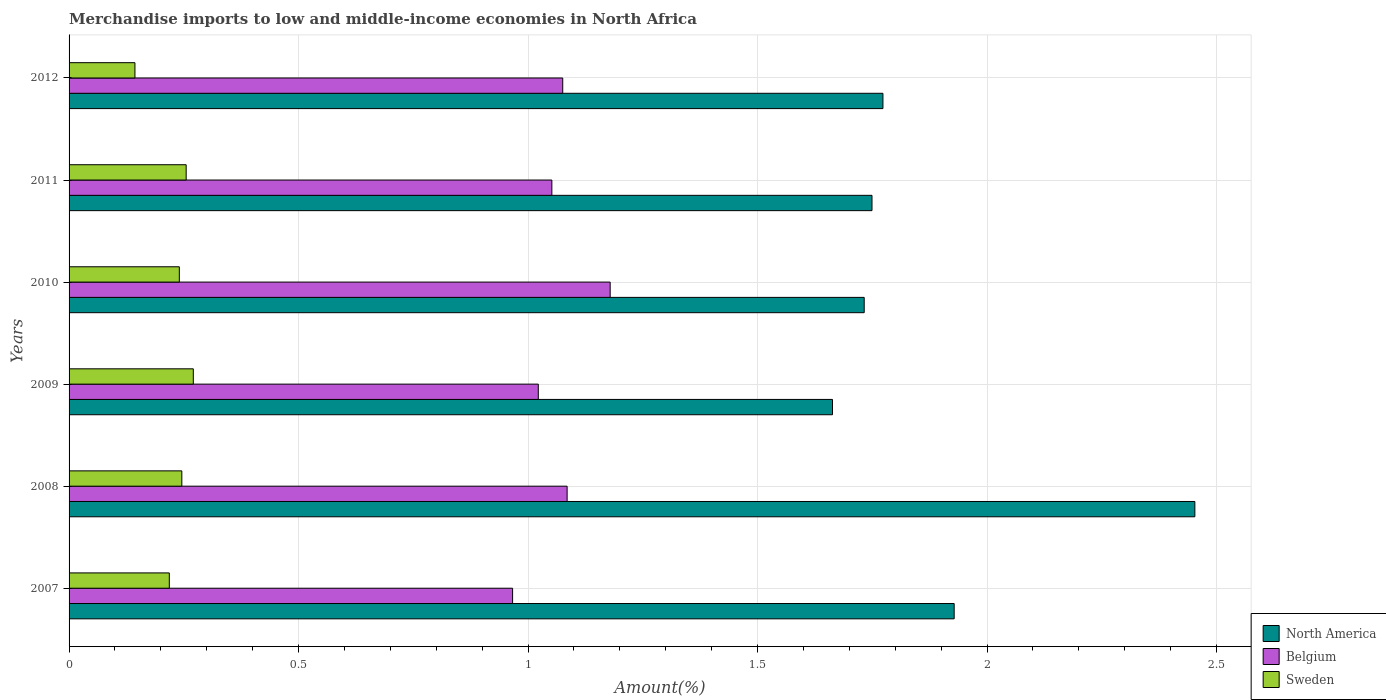How many different coloured bars are there?
Provide a short and direct response. 3. Are the number of bars per tick equal to the number of legend labels?
Provide a short and direct response. Yes. How many bars are there on the 6th tick from the top?
Make the answer very short. 3. What is the label of the 1st group of bars from the top?
Your response must be concise. 2012. What is the percentage of amount earned from merchandise imports in Sweden in 2012?
Offer a very short reply. 0.14. Across all years, what is the maximum percentage of amount earned from merchandise imports in North America?
Make the answer very short. 2.45. Across all years, what is the minimum percentage of amount earned from merchandise imports in Belgium?
Offer a very short reply. 0.97. In which year was the percentage of amount earned from merchandise imports in Sweden minimum?
Ensure brevity in your answer.  2012. What is the total percentage of amount earned from merchandise imports in Belgium in the graph?
Provide a short and direct response. 6.38. What is the difference between the percentage of amount earned from merchandise imports in Belgium in 2008 and that in 2011?
Make the answer very short. 0.03. What is the difference between the percentage of amount earned from merchandise imports in North America in 2010 and the percentage of amount earned from merchandise imports in Sweden in 2012?
Offer a very short reply. 1.59. What is the average percentage of amount earned from merchandise imports in North America per year?
Ensure brevity in your answer.  1.88. In the year 2008, what is the difference between the percentage of amount earned from merchandise imports in Belgium and percentage of amount earned from merchandise imports in North America?
Make the answer very short. -1.37. What is the ratio of the percentage of amount earned from merchandise imports in North America in 2010 to that in 2012?
Provide a succinct answer. 0.98. Is the percentage of amount earned from merchandise imports in North America in 2011 less than that in 2012?
Provide a succinct answer. Yes. What is the difference between the highest and the second highest percentage of amount earned from merchandise imports in Belgium?
Make the answer very short. 0.09. What is the difference between the highest and the lowest percentage of amount earned from merchandise imports in Belgium?
Provide a short and direct response. 0.21. In how many years, is the percentage of amount earned from merchandise imports in North America greater than the average percentage of amount earned from merchandise imports in North America taken over all years?
Your response must be concise. 2. Is the sum of the percentage of amount earned from merchandise imports in North America in 2007 and 2011 greater than the maximum percentage of amount earned from merchandise imports in Sweden across all years?
Give a very brief answer. Yes. What does the 1st bar from the top in 2011 represents?
Offer a very short reply. Sweden. What does the 1st bar from the bottom in 2011 represents?
Offer a terse response. North America. How many bars are there?
Your answer should be very brief. 18. Are all the bars in the graph horizontal?
Make the answer very short. Yes. What is the difference between two consecutive major ticks on the X-axis?
Make the answer very short. 0.5. Are the values on the major ticks of X-axis written in scientific E-notation?
Ensure brevity in your answer.  No. Does the graph contain any zero values?
Make the answer very short. No. How are the legend labels stacked?
Offer a very short reply. Vertical. What is the title of the graph?
Make the answer very short. Merchandise imports to low and middle-income economies in North Africa. Does "Iceland" appear as one of the legend labels in the graph?
Your answer should be very brief. No. What is the label or title of the X-axis?
Provide a short and direct response. Amount(%). What is the label or title of the Y-axis?
Provide a short and direct response. Years. What is the Amount(%) of North America in 2007?
Ensure brevity in your answer.  1.93. What is the Amount(%) in Belgium in 2007?
Offer a very short reply. 0.97. What is the Amount(%) of Sweden in 2007?
Offer a terse response. 0.22. What is the Amount(%) of North America in 2008?
Provide a short and direct response. 2.45. What is the Amount(%) of Belgium in 2008?
Offer a terse response. 1.09. What is the Amount(%) in Sweden in 2008?
Offer a very short reply. 0.25. What is the Amount(%) of North America in 2009?
Your response must be concise. 1.66. What is the Amount(%) of Belgium in 2009?
Your answer should be very brief. 1.02. What is the Amount(%) in Sweden in 2009?
Give a very brief answer. 0.27. What is the Amount(%) of North America in 2010?
Ensure brevity in your answer.  1.73. What is the Amount(%) of Belgium in 2010?
Provide a short and direct response. 1.18. What is the Amount(%) of Sweden in 2010?
Your response must be concise. 0.24. What is the Amount(%) in North America in 2011?
Your answer should be very brief. 1.75. What is the Amount(%) in Belgium in 2011?
Your answer should be very brief. 1.05. What is the Amount(%) in Sweden in 2011?
Keep it short and to the point. 0.26. What is the Amount(%) of North America in 2012?
Offer a terse response. 1.77. What is the Amount(%) of Belgium in 2012?
Offer a very short reply. 1.08. What is the Amount(%) of Sweden in 2012?
Your response must be concise. 0.14. Across all years, what is the maximum Amount(%) of North America?
Make the answer very short. 2.45. Across all years, what is the maximum Amount(%) in Belgium?
Your response must be concise. 1.18. Across all years, what is the maximum Amount(%) in Sweden?
Keep it short and to the point. 0.27. Across all years, what is the minimum Amount(%) in North America?
Your answer should be very brief. 1.66. Across all years, what is the minimum Amount(%) in Belgium?
Your response must be concise. 0.97. Across all years, what is the minimum Amount(%) of Sweden?
Make the answer very short. 0.14. What is the total Amount(%) in North America in the graph?
Your answer should be compact. 11.3. What is the total Amount(%) of Belgium in the graph?
Your answer should be compact. 6.38. What is the total Amount(%) in Sweden in the graph?
Make the answer very short. 1.37. What is the difference between the Amount(%) of North America in 2007 and that in 2008?
Your answer should be compact. -0.52. What is the difference between the Amount(%) of Belgium in 2007 and that in 2008?
Ensure brevity in your answer.  -0.12. What is the difference between the Amount(%) of Sweden in 2007 and that in 2008?
Keep it short and to the point. -0.03. What is the difference between the Amount(%) in North America in 2007 and that in 2009?
Offer a terse response. 0.27. What is the difference between the Amount(%) of Belgium in 2007 and that in 2009?
Your answer should be compact. -0.06. What is the difference between the Amount(%) in Sweden in 2007 and that in 2009?
Keep it short and to the point. -0.05. What is the difference between the Amount(%) in North America in 2007 and that in 2010?
Offer a very short reply. 0.2. What is the difference between the Amount(%) in Belgium in 2007 and that in 2010?
Keep it short and to the point. -0.21. What is the difference between the Amount(%) in Sweden in 2007 and that in 2010?
Provide a short and direct response. -0.02. What is the difference between the Amount(%) of North America in 2007 and that in 2011?
Make the answer very short. 0.18. What is the difference between the Amount(%) in Belgium in 2007 and that in 2011?
Offer a very short reply. -0.09. What is the difference between the Amount(%) in Sweden in 2007 and that in 2011?
Provide a short and direct response. -0.04. What is the difference between the Amount(%) in North America in 2007 and that in 2012?
Ensure brevity in your answer.  0.16. What is the difference between the Amount(%) in Belgium in 2007 and that in 2012?
Offer a very short reply. -0.11. What is the difference between the Amount(%) in Sweden in 2007 and that in 2012?
Your answer should be very brief. 0.07. What is the difference between the Amount(%) of North America in 2008 and that in 2009?
Your answer should be very brief. 0.79. What is the difference between the Amount(%) in Belgium in 2008 and that in 2009?
Provide a succinct answer. 0.06. What is the difference between the Amount(%) of Sweden in 2008 and that in 2009?
Offer a very short reply. -0.03. What is the difference between the Amount(%) of North America in 2008 and that in 2010?
Provide a succinct answer. 0.72. What is the difference between the Amount(%) of Belgium in 2008 and that in 2010?
Your answer should be very brief. -0.09. What is the difference between the Amount(%) of Sweden in 2008 and that in 2010?
Offer a terse response. 0.01. What is the difference between the Amount(%) in North America in 2008 and that in 2011?
Keep it short and to the point. 0.7. What is the difference between the Amount(%) in Sweden in 2008 and that in 2011?
Provide a short and direct response. -0.01. What is the difference between the Amount(%) of North America in 2008 and that in 2012?
Offer a terse response. 0.68. What is the difference between the Amount(%) of Belgium in 2008 and that in 2012?
Your response must be concise. 0.01. What is the difference between the Amount(%) of Sweden in 2008 and that in 2012?
Offer a terse response. 0.1. What is the difference between the Amount(%) of North America in 2009 and that in 2010?
Make the answer very short. -0.07. What is the difference between the Amount(%) in Belgium in 2009 and that in 2010?
Offer a very short reply. -0.16. What is the difference between the Amount(%) in Sweden in 2009 and that in 2010?
Offer a terse response. 0.03. What is the difference between the Amount(%) in North America in 2009 and that in 2011?
Provide a succinct answer. -0.09. What is the difference between the Amount(%) in Belgium in 2009 and that in 2011?
Provide a short and direct response. -0.03. What is the difference between the Amount(%) of Sweden in 2009 and that in 2011?
Your answer should be very brief. 0.02. What is the difference between the Amount(%) in North America in 2009 and that in 2012?
Ensure brevity in your answer.  -0.11. What is the difference between the Amount(%) in Belgium in 2009 and that in 2012?
Your response must be concise. -0.05. What is the difference between the Amount(%) of Sweden in 2009 and that in 2012?
Provide a succinct answer. 0.13. What is the difference between the Amount(%) in North America in 2010 and that in 2011?
Provide a succinct answer. -0.02. What is the difference between the Amount(%) in Belgium in 2010 and that in 2011?
Provide a short and direct response. 0.13. What is the difference between the Amount(%) in Sweden in 2010 and that in 2011?
Your answer should be compact. -0.01. What is the difference between the Amount(%) in North America in 2010 and that in 2012?
Give a very brief answer. -0.04. What is the difference between the Amount(%) in Belgium in 2010 and that in 2012?
Your answer should be very brief. 0.1. What is the difference between the Amount(%) of Sweden in 2010 and that in 2012?
Ensure brevity in your answer.  0.1. What is the difference between the Amount(%) of North America in 2011 and that in 2012?
Offer a terse response. -0.02. What is the difference between the Amount(%) in Belgium in 2011 and that in 2012?
Give a very brief answer. -0.02. What is the difference between the Amount(%) in Sweden in 2011 and that in 2012?
Ensure brevity in your answer.  0.11. What is the difference between the Amount(%) of North America in 2007 and the Amount(%) of Belgium in 2008?
Make the answer very short. 0.84. What is the difference between the Amount(%) in North America in 2007 and the Amount(%) in Sweden in 2008?
Provide a succinct answer. 1.68. What is the difference between the Amount(%) of Belgium in 2007 and the Amount(%) of Sweden in 2008?
Your answer should be compact. 0.72. What is the difference between the Amount(%) in North America in 2007 and the Amount(%) in Belgium in 2009?
Give a very brief answer. 0.91. What is the difference between the Amount(%) of North America in 2007 and the Amount(%) of Sweden in 2009?
Keep it short and to the point. 1.66. What is the difference between the Amount(%) in Belgium in 2007 and the Amount(%) in Sweden in 2009?
Your answer should be compact. 0.7. What is the difference between the Amount(%) of North America in 2007 and the Amount(%) of Belgium in 2010?
Offer a very short reply. 0.75. What is the difference between the Amount(%) of North America in 2007 and the Amount(%) of Sweden in 2010?
Your answer should be very brief. 1.69. What is the difference between the Amount(%) in Belgium in 2007 and the Amount(%) in Sweden in 2010?
Your answer should be very brief. 0.73. What is the difference between the Amount(%) of North America in 2007 and the Amount(%) of Belgium in 2011?
Offer a very short reply. 0.88. What is the difference between the Amount(%) of North America in 2007 and the Amount(%) of Sweden in 2011?
Offer a very short reply. 1.67. What is the difference between the Amount(%) in Belgium in 2007 and the Amount(%) in Sweden in 2011?
Make the answer very short. 0.71. What is the difference between the Amount(%) in North America in 2007 and the Amount(%) in Belgium in 2012?
Provide a succinct answer. 0.85. What is the difference between the Amount(%) in North America in 2007 and the Amount(%) in Sweden in 2012?
Provide a succinct answer. 1.78. What is the difference between the Amount(%) of Belgium in 2007 and the Amount(%) of Sweden in 2012?
Provide a short and direct response. 0.82. What is the difference between the Amount(%) of North America in 2008 and the Amount(%) of Belgium in 2009?
Ensure brevity in your answer.  1.43. What is the difference between the Amount(%) in North America in 2008 and the Amount(%) in Sweden in 2009?
Your answer should be very brief. 2.18. What is the difference between the Amount(%) of Belgium in 2008 and the Amount(%) of Sweden in 2009?
Give a very brief answer. 0.81. What is the difference between the Amount(%) in North America in 2008 and the Amount(%) in Belgium in 2010?
Offer a very short reply. 1.27. What is the difference between the Amount(%) in North America in 2008 and the Amount(%) in Sweden in 2010?
Your answer should be very brief. 2.21. What is the difference between the Amount(%) in Belgium in 2008 and the Amount(%) in Sweden in 2010?
Ensure brevity in your answer.  0.84. What is the difference between the Amount(%) of North America in 2008 and the Amount(%) of Belgium in 2011?
Offer a terse response. 1.4. What is the difference between the Amount(%) in North America in 2008 and the Amount(%) in Sweden in 2011?
Your answer should be compact. 2.2. What is the difference between the Amount(%) of Belgium in 2008 and the Amount(%) of Sweden in 2011?
Provide a succinct answer. 0.83. What is the difference between the Amount(%) of North America in 2008 and the Amount(%) of Belgium in 2012?
Give a very brief answer. 1.38. What is the difference between the Amount(%) of North America in 2008 and the Amount(%) of Sweden in 2012?
Offer a very short reply. 2.31. What is the difference between the Amount(%) in Belgium in 2008 and the Amount(%) in Sweden in 2012?
Your response must be concise. 0.94. What is the difference between the Amount(%) in North America in 2009 and the Amount(%) in Belgium in 2010?
Your answer should be compact. 0.48. What is the difference between the Amount(%) in North America in 2009 and the Amount(%) in Sweden in 2010?
Your response must be concise. 1.42. What is the difference between the Amount(%) in Belgium in 2009 and the Amount(%) in Sweden in 2010?
Your response must be concise. 0.78. What is the difference between the Amount(%) in North America in 2009 and the Amount(%) in Belgium in 2011?
Your response must be concise. 0.61. What is the difference between the Amount(%) in North America in 2009 and the Amount(%) in Sweden in 2011?
Offer a very short reply. 1.41. What is the difference between the Amount(%) of Belgium in 2009 and the Amount(%) of Sweden in 2011?
Make the answer very short. 0.77. What is the difference between the Amount(%) in North America in 2009 and the Amount(%) in Belgium in 2012?
Give a very brief answer. 0.59. What is the difference between the Amount(%) of North America in 2009 and the Amount(%) of Sweden in 2012?
Your answer should be compact. 1.52. What is the difference between the Amount(%) in Belgium in 2009 and the Amount(%) in Sweden in 2012?
Provide a short and direct response. 0.88. What is the difference between the Amount(%) of North America in 2010 and the Amount(%) of Belgium in 2011?
Provide a short and direct response. 0.68. What is the difference between the Amount(%) of North America in 2010 and the Amount(%) of Sweden in 2011?
Keep it short and to the point. 1.48. What is the difference between the Amount(%) of Belgium in 2010 and the Amount(%) of Sweden in 2011?
Provide a short and direct response. 0.92. What is the difference between the Amount(%) in North America in 2010 and the Amount(%) in Belgium in 2012?
Provide a succinct answer. 0.66. What is the difference between the Amount(%) of North America in 2010 and the Amount(%) of Sweden in 2012?
Your answer should be compact. 1.59. What is the difference between the Amount(%) in Belgium in 2010 and the Amount(%) in Sweden in 2012?
Offer a terse response. 1.04. What is the difference between the Amount(%) of North America in 2011 and the Amount(%) of Belgium in 2012?
Give a very brief answer. 0.67. What is the difference between the Amount(%) of North America in 2011 and the Amount(%) of Sweden in 2012?
Offer a terse response. 1.61. What is the difference between the Amount(%) of Belgium in 2011 and the Amount(%) of Sweden in 2012?
Your answer should be very brief. 0.91. What is the average Amount(%) of North America per year?
Provide a short and direct response. 1.88. What is the average Amount(%) of Belgium per year?
Keep it short and to the point. 1.06. What is the average Amount(%) in Sweden per year?
Provide a succinct answer. 0.23. In the year 2007, what is the difference between the Amount(%) in North America and Amount(%) in Belgium?
Ensure brevity in your answer.  0.96. In the year 2007, what is the difference between the Amount(%) of North America and Amount(%) of Sweden?
Provide a short and direct response. 1.71. In the year 2007, what is the difference between the Amount(%) in Belgium and Amount(%) in Sweden?
Keep it short and to the point. 0.75. In the year 2008, what is the difference between the Amount(%) in North America and Amount(%) in Belgium?
Offer a terse response. 1.37. In the year 2008, what is the difference between the Amount(%) of North America and Amount(%) of Sweden?
Ensure brevity in your answer.  2.21. In the year 2008, what is the difference between the Amount(%) in Belgium and Amount(%) in Sweden?
Ensure brevity in your answer.  0.84. In the year 2009, what is the difference between the Amount(%) in North America and Amount(%) in Belgium?
Your answer should be very brief. 0.64. In the year 2009, what is the difference between the Amount(%) of North America and Amount(%) of Sweden?
Keep it short and to the point. 1.39. In the year 2009, what is the difference between the Amount(%) of Belgium and Amount(%) of Sweden?
Your answer should be very brief. 0.75. In the year 2010, what is the difference between the Amount(%) in North America and Amount(%) in Belgium?
Provide a succinct answer. 0.55. In the year 2010, what is the difference between the Amount(%) in North America and Amount(%) in Sweden?
Offer a very short reply. 1.49. In the year 2010, what is the difference between the Amount(%) of Belgium and Amount(%) of Sweden?
Offer a very short reply. 0.94. In the year 2011, what is the difference between the Amount(%) in North America and Amount(%) in Belgium?
Your response must be concise. 0.7. In the year 2011, what is the difference between the Amount(%) in North America and Amount(%) in Sweden?
Your answer should be compact. 1.49. In the year 2011, what is the difference between the Amount(%) in Belgium and Amount(%) in Sweden?
Keep it short and to the point. 0.8. In the year 2012, what is the difference between the Amount(%) in North America and Amount(%) in Belgium?
Your response must be concise. 0.7. In the year 2012, what is the difference between the Amount(%) of North America and Amount(%) of Sweden?
Your answer should be compact. 1.63. In the year 2012, what is the difference between the Amount(%) of Belgium and Amount(%) of Sweden?
Give a very brief answer. 0.93. What is the ratio of the Amount(%) in North America in 2007 to that in 2008?
Keep it short and to the point. 0.79. What is the ratio of the Amount(%) of Belgium in 2007 to that in 2008?
Give a very brief answer. 0.89. What is the ratio of the Amount(%) in Sweden in 2007 to that in 2008?
Your answer should be very brief. 0.89. What is the ratio of the Amount(%) in North America in 2007 to that in 2009?
Ensure brevity in your answer.  1.16. What is the ratio of the Amount(%) of Belgium in 2007 to that in 2009?
Provide a succinct answer. 0.95. What is the ratio of the Amount(%) in Sweden in 2007 to that in 2009?
Provide a short and direct response. 0.81. What is the ratio of the Amount(%) in North America in 2007 to that in 2010?
Provide a succinct answer. 1.11. What is the ratio of the Amount(%) in Belgium in 2007 to that in 2010?
Make the answer very short. 0.82. What is the ratio of the Amount(%) in Sweden in 2007 to that in 2010?
Give a very brief answer. 0.91. What is the ratio of the Amount(%) in North America in 2007 to that in 2011?
Give a very brief answer. 1.1. What is the ratio of the Amount(%) in Belgium in 2007 to that in 2011?
Provide a short and direct response. 0.92. What is the ratio of the Amount(%) in Sweden in 2007 to that in 2011?
Your answer should be compact. 0.86. What is the ratio of the Amount(%) in North America in 2007 to that in 2012?
Your answer should be very brief. 1.09. What is the ratio of the Amount(%) in Belgium in 2007 to that in 2012?
Make the answer very short. 0.9. What is the ratio of the Amount(%) of Sweden in 2007 to that in 2012?
Give a very brief answer. 1.52. What is the ratio of the Amount(%) in North America in 2008 to that in 2009?
Your answer should be very brief. 1.47. What is the ratio of the Amount(%) of Belgium in 2008 to that in 2009?
Offer a terse response. 1.06. What is the ratio of the Amount(%) in Sweden in 2008 to that in 2009?
Offer a terse response. 0.91. What is the ratio of the Amount(%) of North America in 2008 to that in 2010?
Ensure brevity in your answer.  1.42. What is the ratio of the Amount(%) in Belgium in 2008 to that in 2010?
Offer a terse response. 0.92. What is the ratio of the Amount(%) in Sweden in 2008 to that in 2010?
Make the answer very short. 1.02. What is the ratio of the Amount(%) of North America in 2008 to that in 2011?
Keep it short and to the point. 1.4. What is the ratio of the Amount(%) in Belgium in 2008 to that in 2011?
Ensure brevity in your answer.  1.03. What is the ratio of the Amount(%) of Sweden in 2008 to that in 2011?
Provide a succinct answer. 0.96. What is the ratio of the Amount(%) in North America in 2008 to that in 2012?
Your answer should be compact. 1.38. What is the ratio of the Amount(%) of Belgium in 2008 to that in 2012?
Give a very brief answer. 1.01. What is the ratio of the Amount(%) of Sweden in 2008 to that in 2012?
Your answer should be very brief. 1.71. What is the ratio of the Amount(%) in North America in 2009 to that in 2010?
Your answer should be very brief. 0.96. What is the ratio of the Amount(%) of Belgium in 2009 to that in 2010?
Provide a succinct answer. 0.87. What is the ratio of the Amount(%) of Sweden in 2009 to that in 2010?
Your answer should be very brief. 1.13. What is the ratio of the Amount(%) in North America in 2009 to that in 2011?
Offer a terse response. 0.95. What is the ratio of the Amount(%) of Belgium in 2009 to that in 2011?
Provide a short and direct response. 0.97. What is the ratio of the Amount(%) in Sweden in 2009 to that in 2011?
Provide a short and direct response. 1.06. What is the ratio of the Amount(%) in North America in 2009 to that in 2012?
Ensure brevity in your answer.  0.94. What is the ratio of the Amount(%) of Belgium in 2009 to that in 2012?
Keep it short and to the point. 0.95. What is the ratio of the Amount(%) of Sweden in 2009 to that in 2012?
Provide a short and direct response. 1.89. What is the ratio of the Amount(%) of North America in 2010 to that in 2011?
Ensure brevity in your answer.  0.99. What is the ratio of the Amount(%) of Belgium in 2010 to that in 2011?
Keep it short and to the point. 1.12. What is the ratio of the Amount(%) of Sweden in 2010 to that in 2011?
Give a very brief answer. 0.94. What is the ratio of the Amount(%) in North America in 2010 to that in 2012?
Provide a short and direct response. 0.98. What is the ratio of the Amount(%) in Belgium in 2010 to that in 2012?
Provide a succinct answer. 1.1. What is the ratio of the Amount(%) of Sweden in 2010 to that in 2012?
Offer a terse response. 1.67. What is the ratio of the Amount(%) in North America in 2011 to that in 2012?
Offer a terse response. 0.99. What is the ratio of the Amount(%) of Sweden in 2011 to that in 2012?
Offer a very short reply. 1.78. What is the difference between the highest and the second highest Amount(%) of North America?
Provide a short and direct response. 0.52. What is the difference between the highest and the second highest Amount(%) of Belgium?
Your answer should be very brief. 0.09. What is the difference between the highest and the second highest Amount(%) in Sweden?
Your answer should be very brief. 0.02. What is the difference between the highest and the lowest Amount(%) in North America?
Ensure brevity in your answer.  0.79. What is the difference between the highest and the lowest Amount(%) in Belgium?
Give a very brief answer. 0.21. What is the difference between the highest and the lowest Amount(%) in Sweden?
Your answer should be very brief. 0.13. 